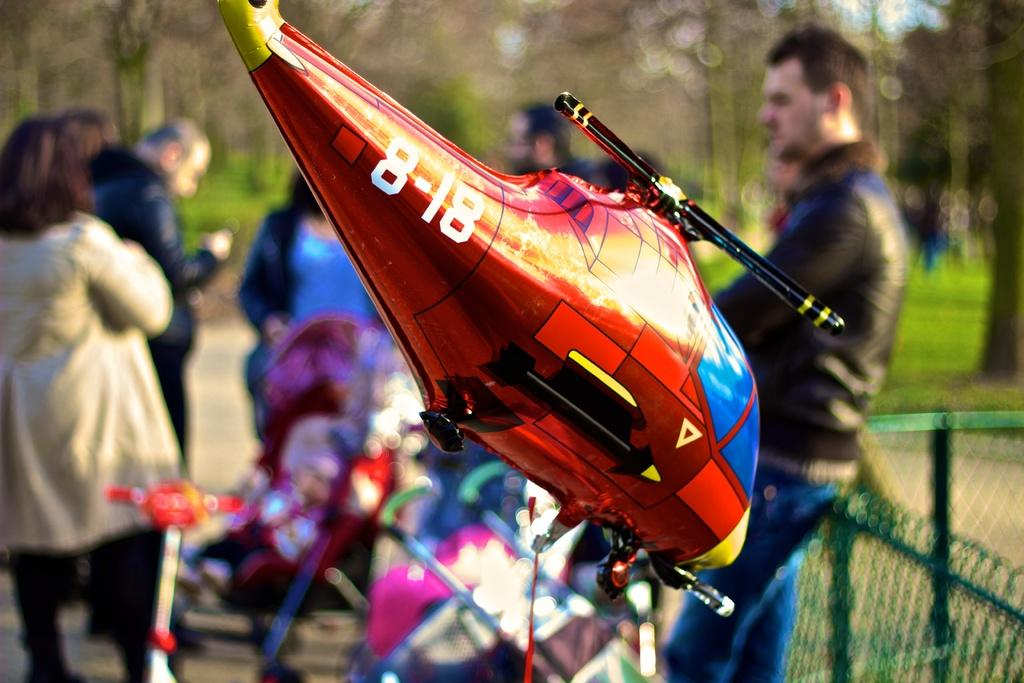<image>
Relay a brief, clear account of the picture shown. A toy balloon helicopter with the number 8-18 written on the tail 